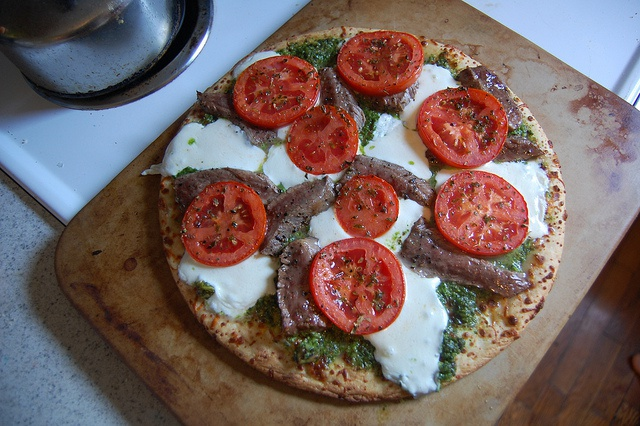Describe the objects in this image and their specific colors. I can see pizza in black, maroon, brown, and gray tones and oven in black, lightblue, and darkgray tones in this image. 